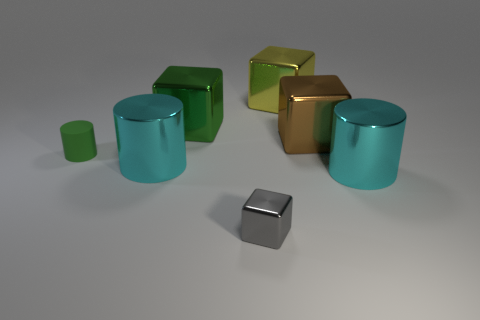Subtract 1 cubes. How many cubes are left? 3 Subtract all red cubes. Subtract all brown cylinders. How many cubes are left? 4 Add 3 small green rubber objects. How many objects exist? 10 Subtract all cylinders. How many objects are left? 4 Add 6 cyan objects. How many cyan objects exist? 8 Subtract 0 brown spheres. How many objects are left? 7 Subtract all yellow shiny objects. Subtract all small green rubber cylinders. How many objects are left? 5 Add 3 green things. How many green things are left? 5 